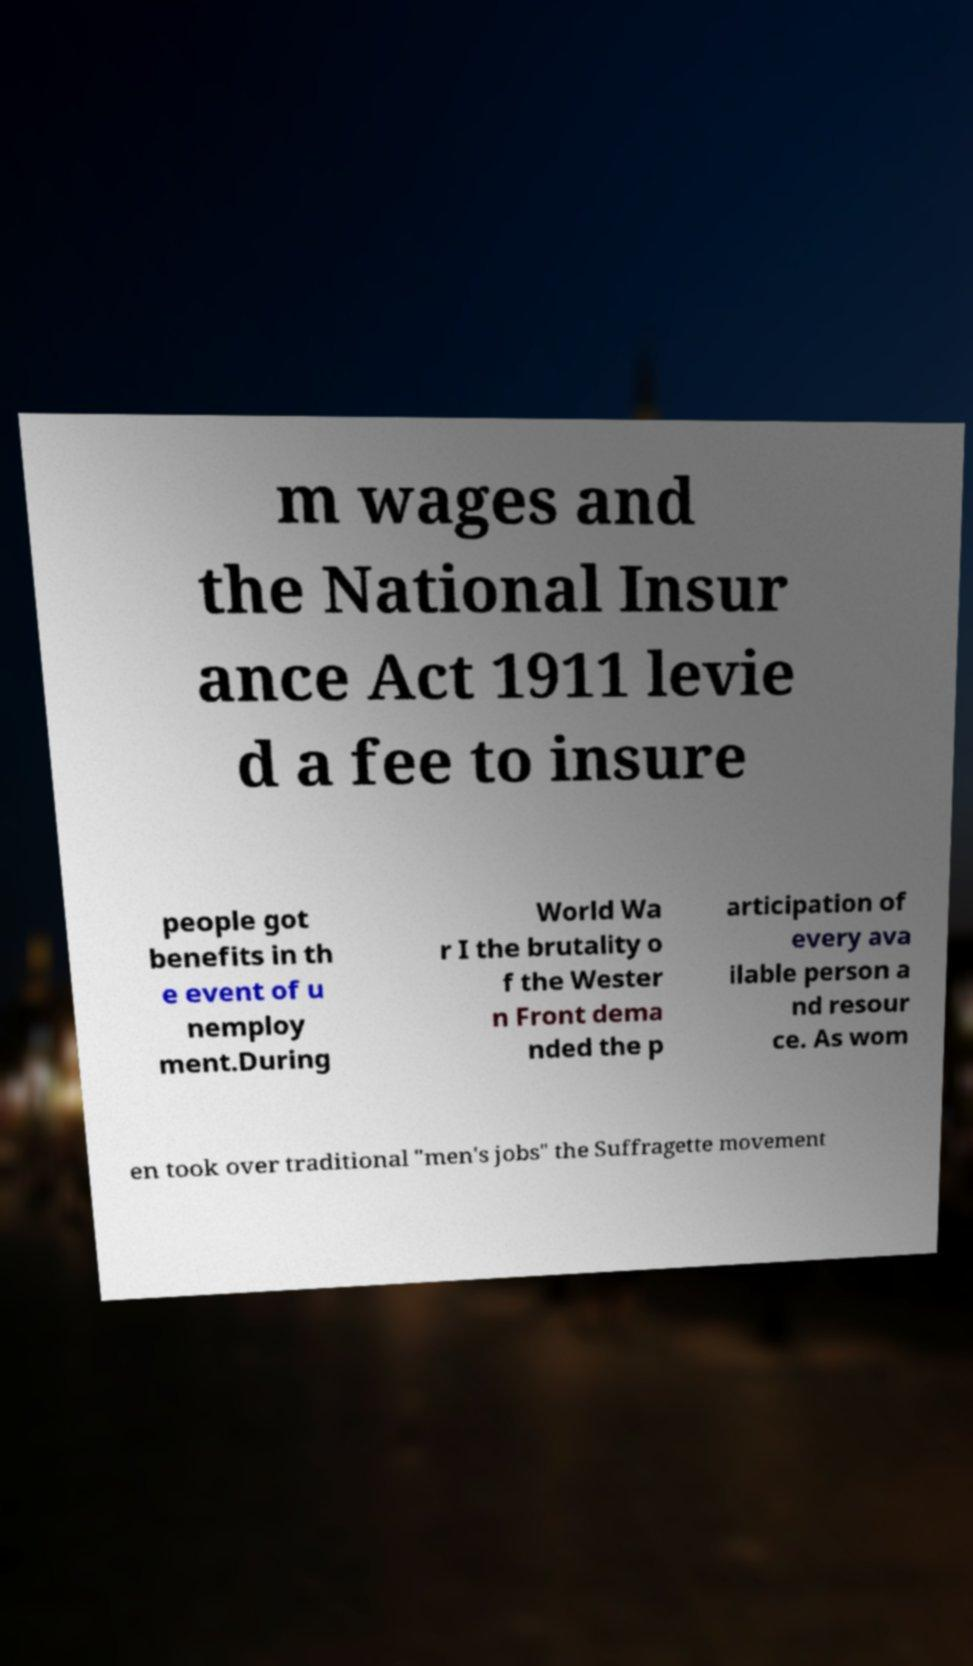Please identify and transcribe the text found in this image. m wages and the National Insur ance Act 1911 levie d a fee to insure people got benefits in th e event of u nemploy ment.During World Wa r I the brutality o f the Wester n Front dema nded the p articipation of every ava ilable person a nd resour ce. As wom en took over traditional "men's jobs" the Suffragette movement 